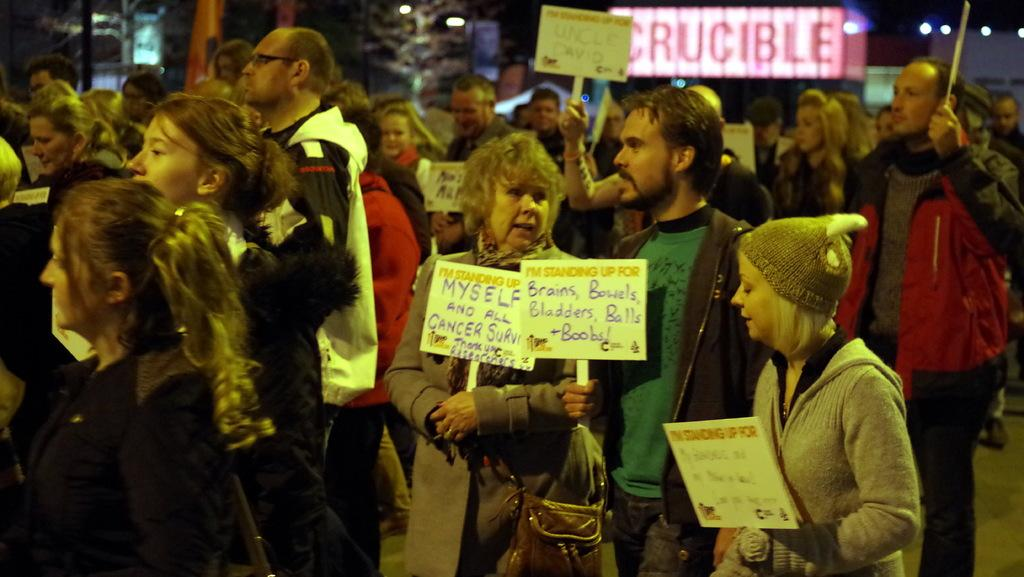What is happening on the road in the image? There are many people on the road in the image. What are some of the people doing in the image? Some of the people are holding placards. What can be seen in the background of the image? There are buildings and trees in the background of the image. What type of celery is being used as a prop in the image? There is no celery present in the image. Where is the bedroom located in the image? There is no bedroom present in the image. 